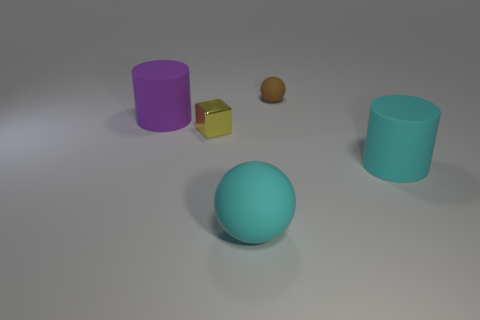Add 1 tiny brown rubber spheres. How many objects exist? 6 Subtract all cylinders. How many objects are left? 3 Add 2 big green spheres. How many big green spheres exist? 2 Subtract 0 blue balls. How many objects are left? 5 Subtract all small rubber things. Subtract all big purple cylinders. How many objects are left? 3 Add 4 purple cylinders. How many purple cylinders are left? 5 